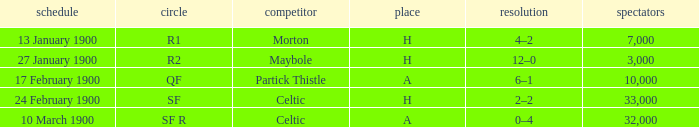Who played against in venue a on 17 february 1900? Partick Thistle. 